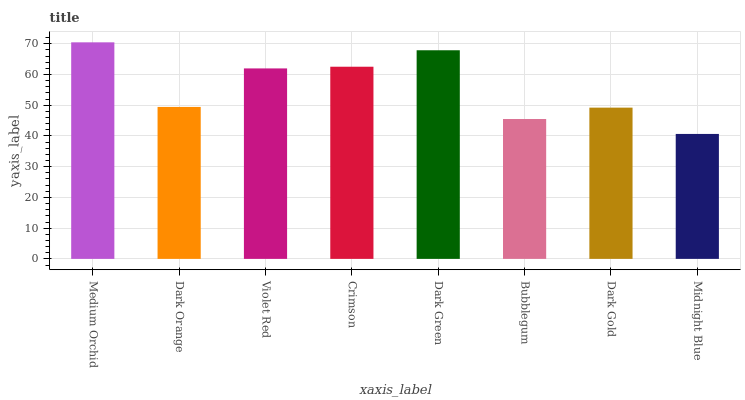Is Midnight Blue the minimum?
Answer yes or no. Yes. Is Medium Orchid the maximum?
Answer yes or no. Yes. Is Dark Orange the minimum?
Answer yes or no. No. Is Dark Orange the maximum?
Answer yes or no. No. Is Medium Orchid greater than Dark Orange?
Answer yes or no. Yes. Is Dark Orange less than Medium Orchid?
Answer yes or no. Yes. Is Dark Orange greater than Medium Orchid?
Answer yes or no. No. Is Medium Orchid less than Dark Orange?
Answer yes or no. No. Is Violet Red the high median?
Answer yes or no. Yes. Is Dark Orange the low median?
Answer yes or no. Yes. Is Dark Gold the high median?
Answer yes or no. No. Is Midnight Blue the low median?
Answer yes or no. No. 